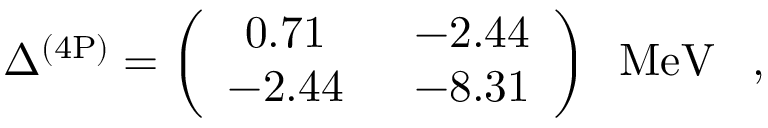Convert formula to latex. <formula><loc_0><loc_0><loc_500><loc_500>\Delta ^ { ( 4 P ) } = \left ( \begin{array} { c c } { 0 . 7 1 \, } & { \, - 2 . 4 4 } \\ { - 2 . 4 4 \, } & { \, - 8 . 3 1 } \end{array} \right ) \, M e V \, ,</formula> 